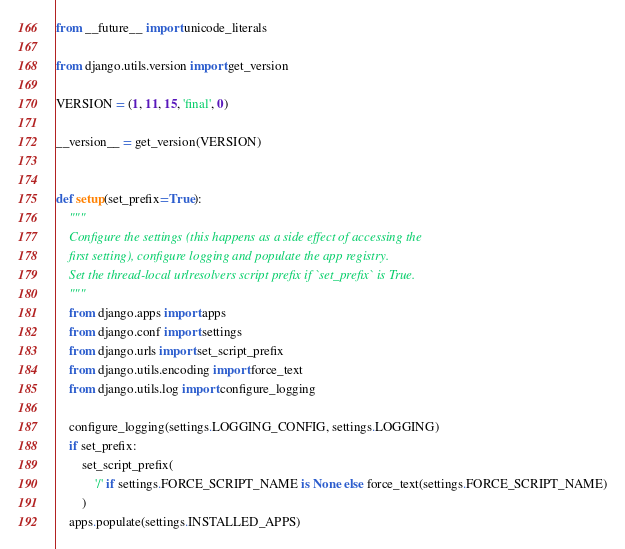<code> <loc_0><loc_0><loc_500><loc_500><_Python_>from __future__ import unicode_literals

from django.utils.version import get_version

VERSION = (1, 11, 15, 'final', 0)

__version__ = get_version(VERSION)


def setup(set_prefix=True):
    """
    Configure the settings (this happens as a side effect of accessing the
    first setting), configure logging and populate the app registry.
    Set the thread-local urlresolvers script prefix if `set_prefix` is True.
    """
    from django.apps import apps
    from django.conf import settings
    from django.urls import set_script_prefix
    from django.utils.encoding import force_text
    from django.utils.log import configure_logging

    configure_logging(settings.LOGGING_CONFIG, settings.LOGGING)
    if set_prefix:
        set_script_prefix(
            '/' if settings.FORCE_SCRIPT_NAME is None else force_text(settings.FORCE_SCRIPT_NAME)
        )
    apps.populate(settings.INSTALLED_APPS)
</code> 